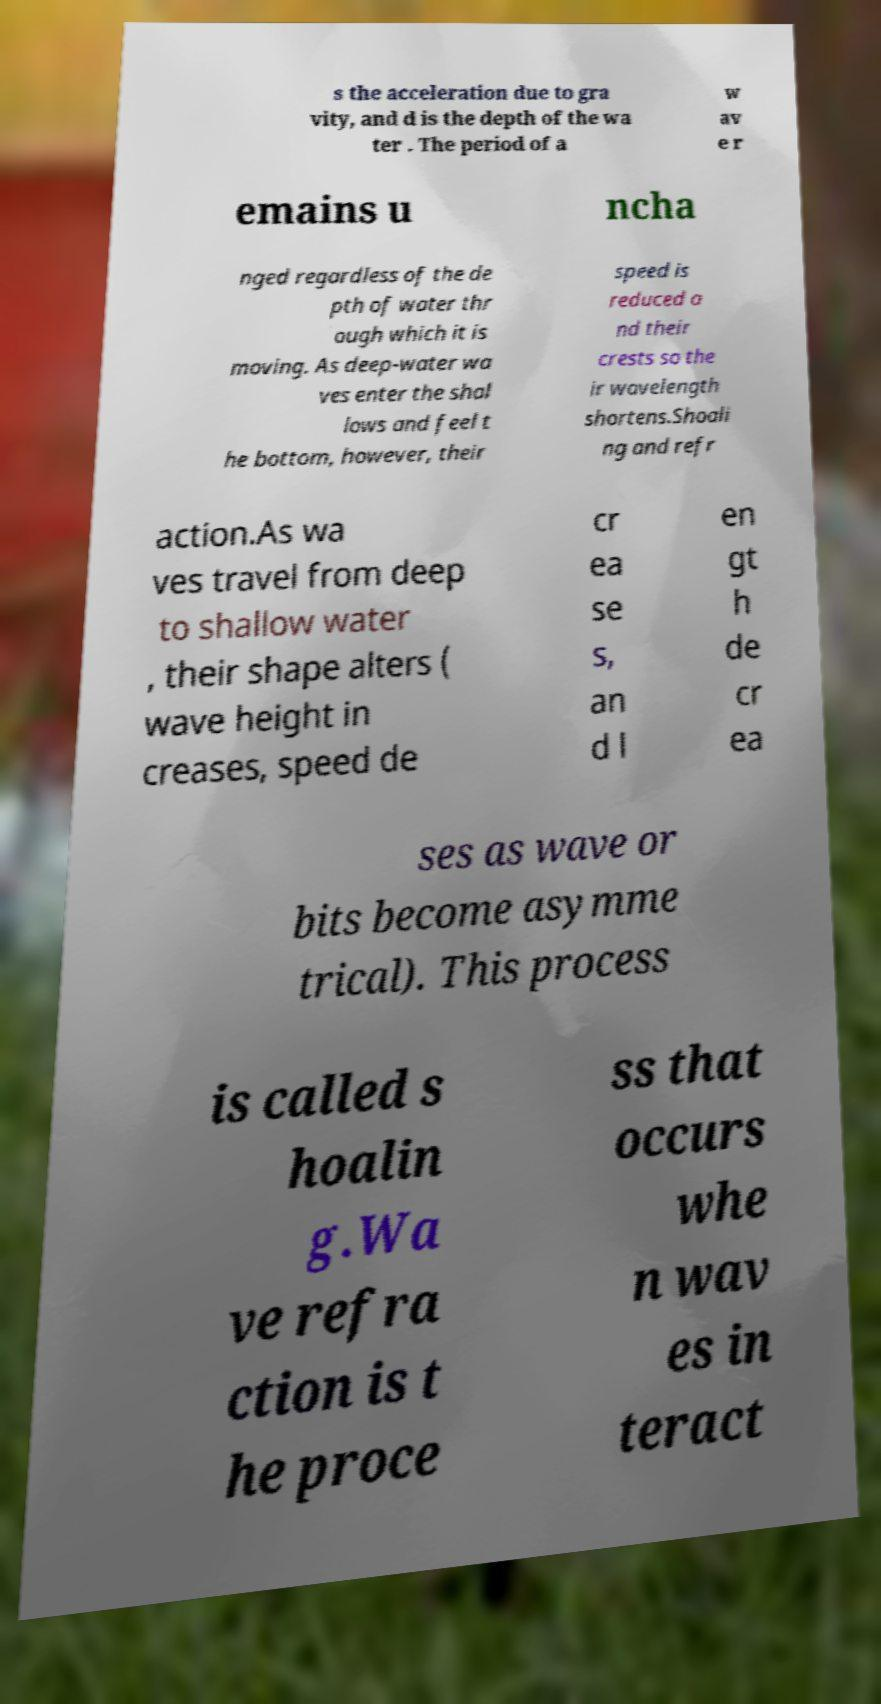Could you extract and type out the text from this image? s the acceleration due to gra vity, and d is the depth of the wa ter . The period of a w av e r emains u ncha nged regardless of the de pth of water thr ough which it is moving. As deep-water wa ves enter the shal lows and feel t he bottom, however, their speed is reduced a nd their crests so the ir wavelength shortens.Shoali ng and refr action.As wa ves travel from deep to shallow water , their shape alters ( wave height in creases, speed de cr ea se s, an d l en gt h de cr ea ses as wave or bits become asymme trical). This process is called s hoalin g.Wa ve refra ction is t he proce ss that occurs whe n wav es in teract 